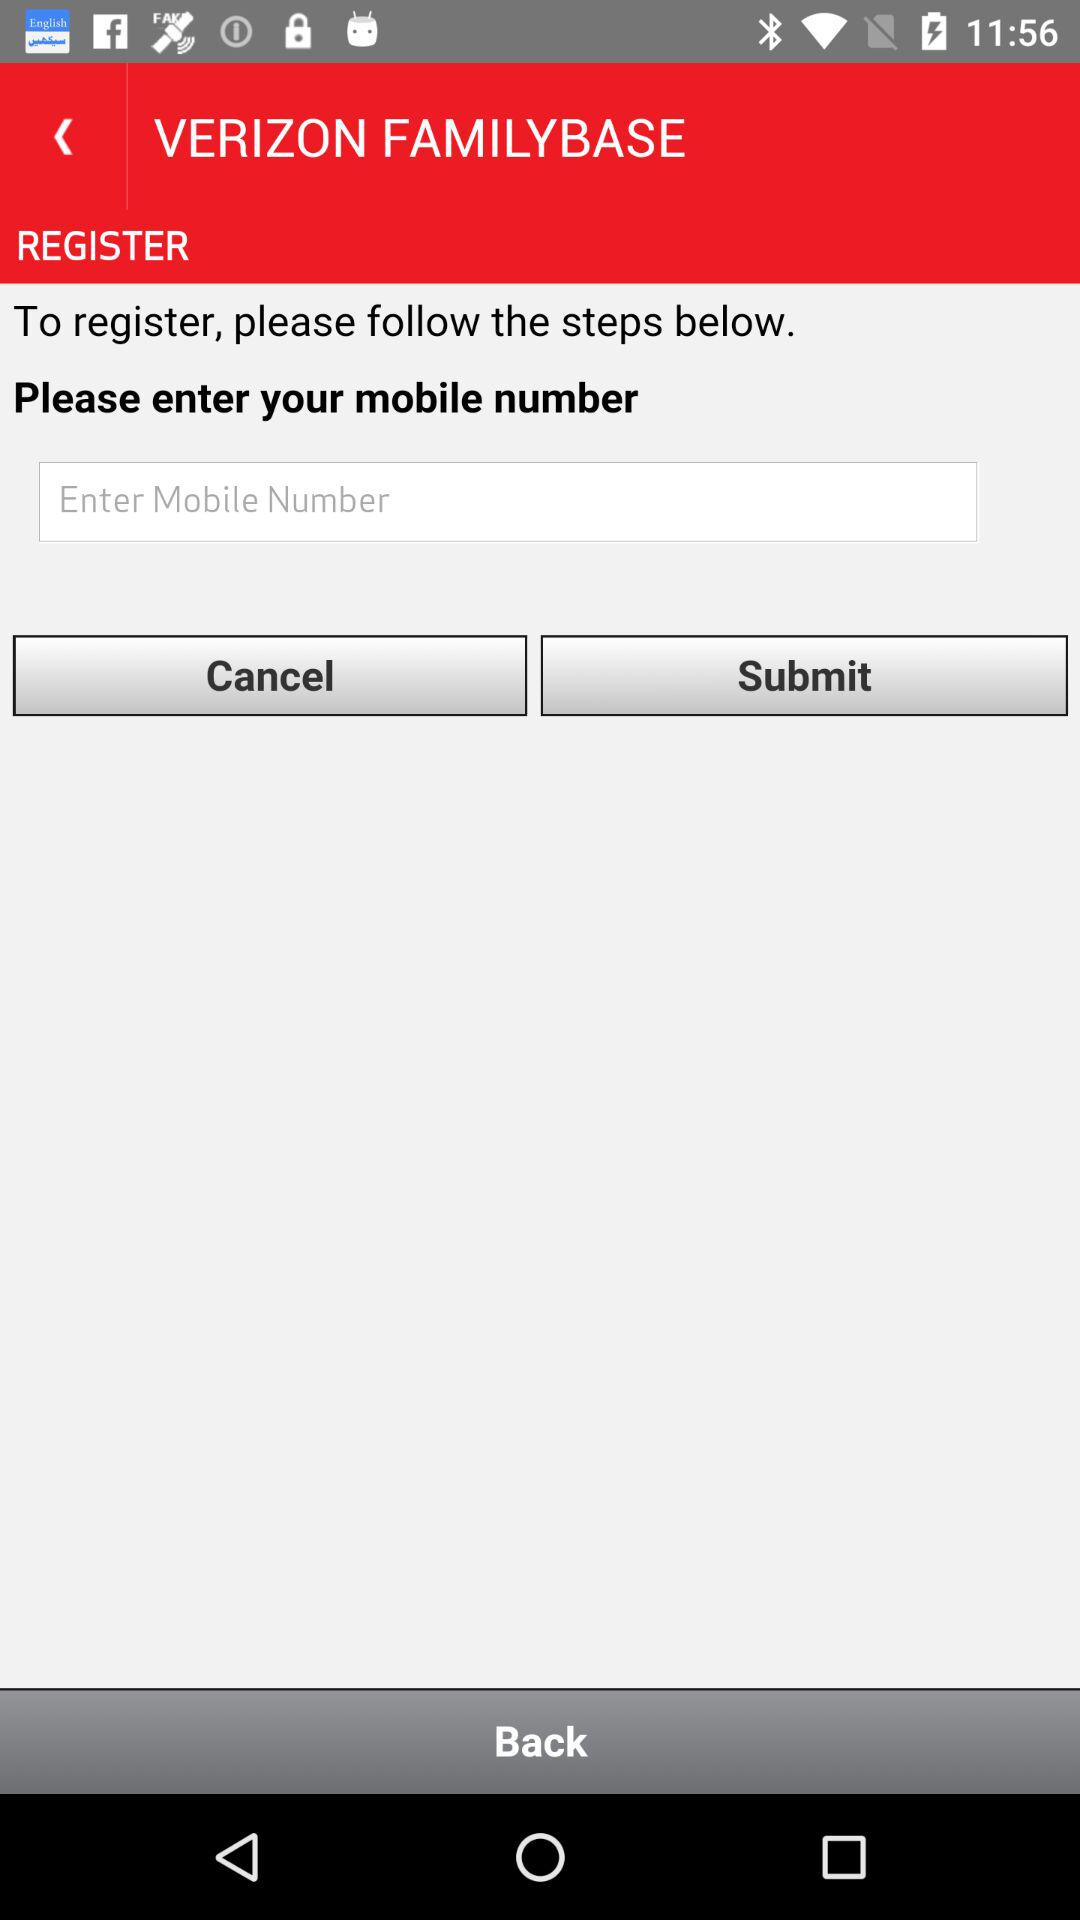What is the name of the application?
When the provided information is insufficient, respond with <no answer>. <no answer> 